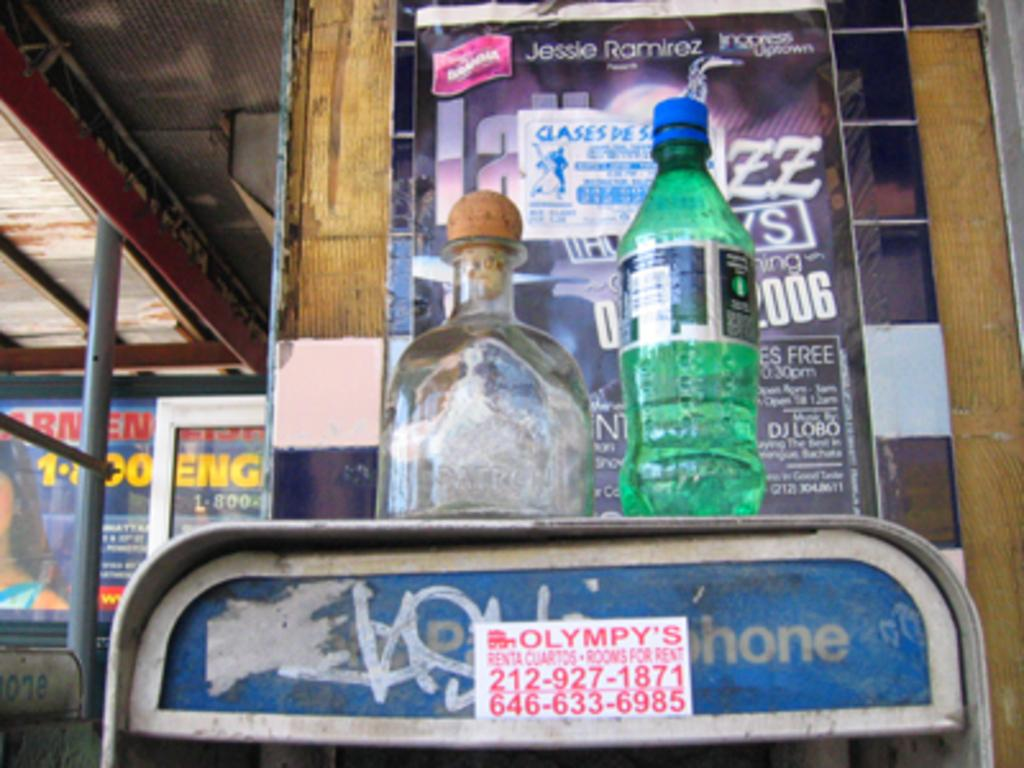<image>
Render a clear and concise summary of the photo. Two bottles sitting on top of a phone booth with an advertisement for Olympy's rooms for rent. 